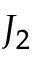Convert formula to latex. <formula><loc_0><loc_0><loc_500><loc_500>J _ { 2 }</formula> 